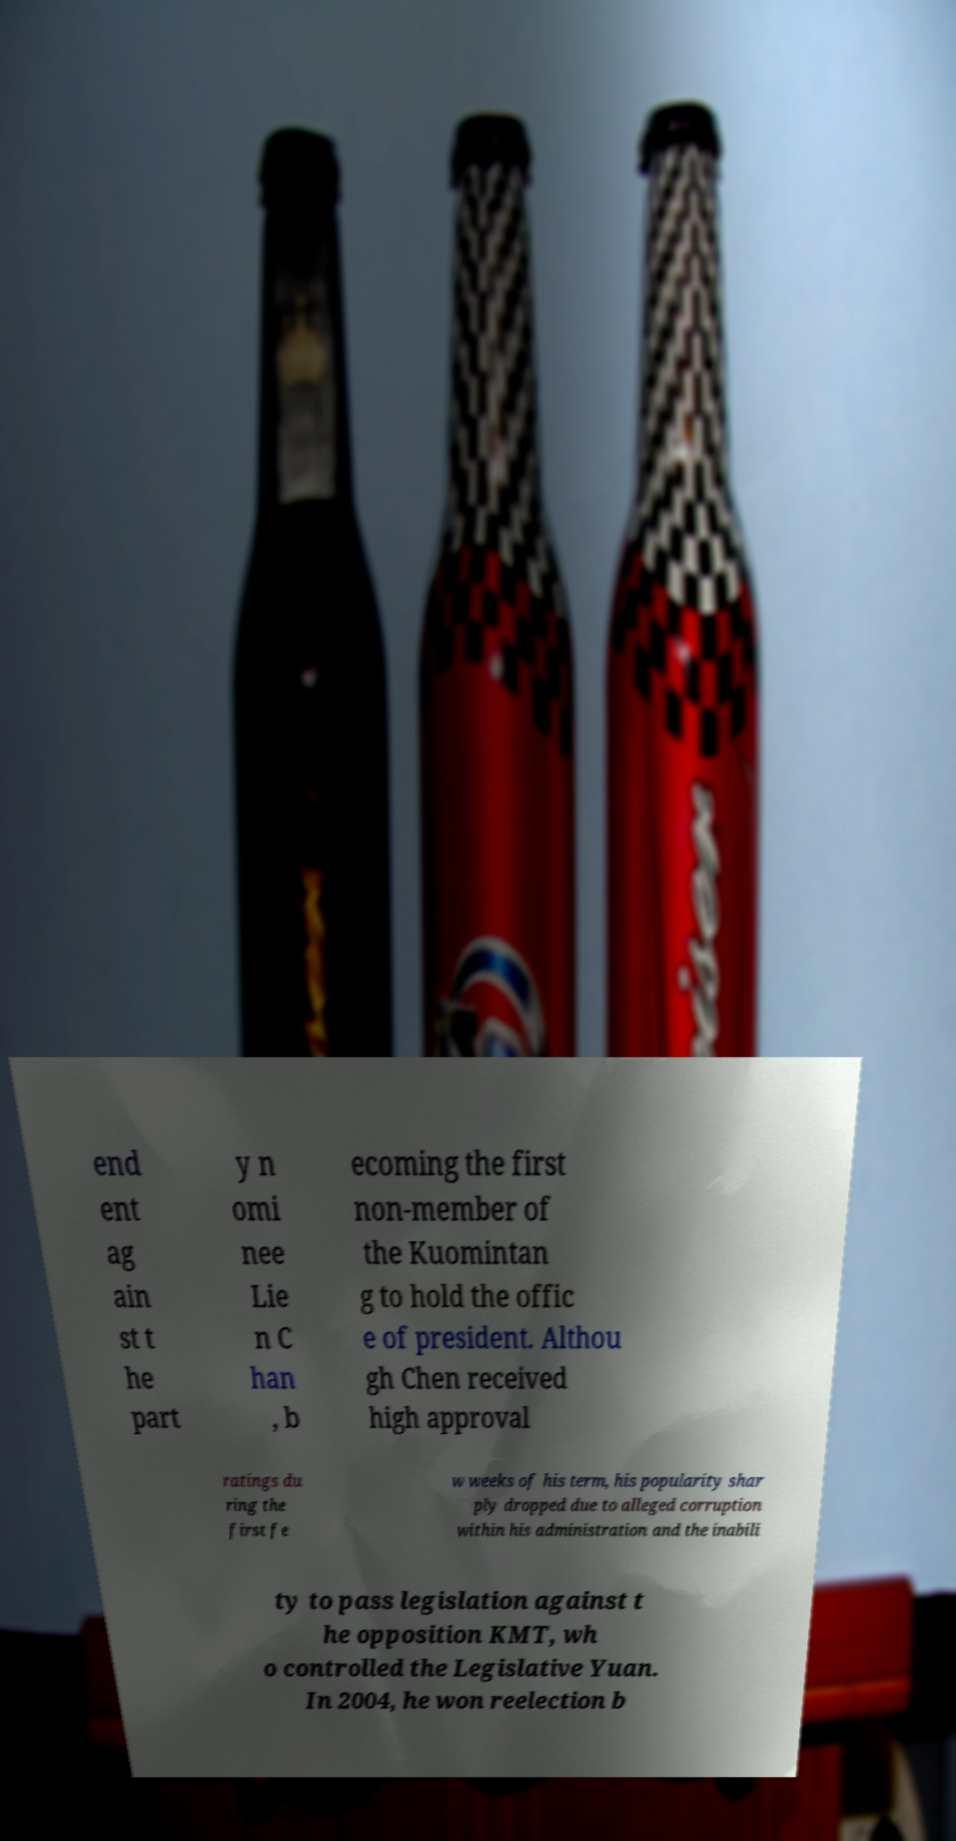Can you read and provide the text displayed in the image?This photo seems to have some interesting text. Can you extract and type it out for me? end ent ag ain st t he part y n omi nee Lie n C han , b ecoming the first non-member of the Kuomintan g to hold the offic e of president. Althou gh Chen received high approval ratings du ring the first fe w weeks of his term, his popularity shar ply dropped due to alleged corruption within his administration and the inabili ty to pass legislation against t he opposition KMT, wh o controlled the Legislative Yuan. In 2004, he won reelection b 